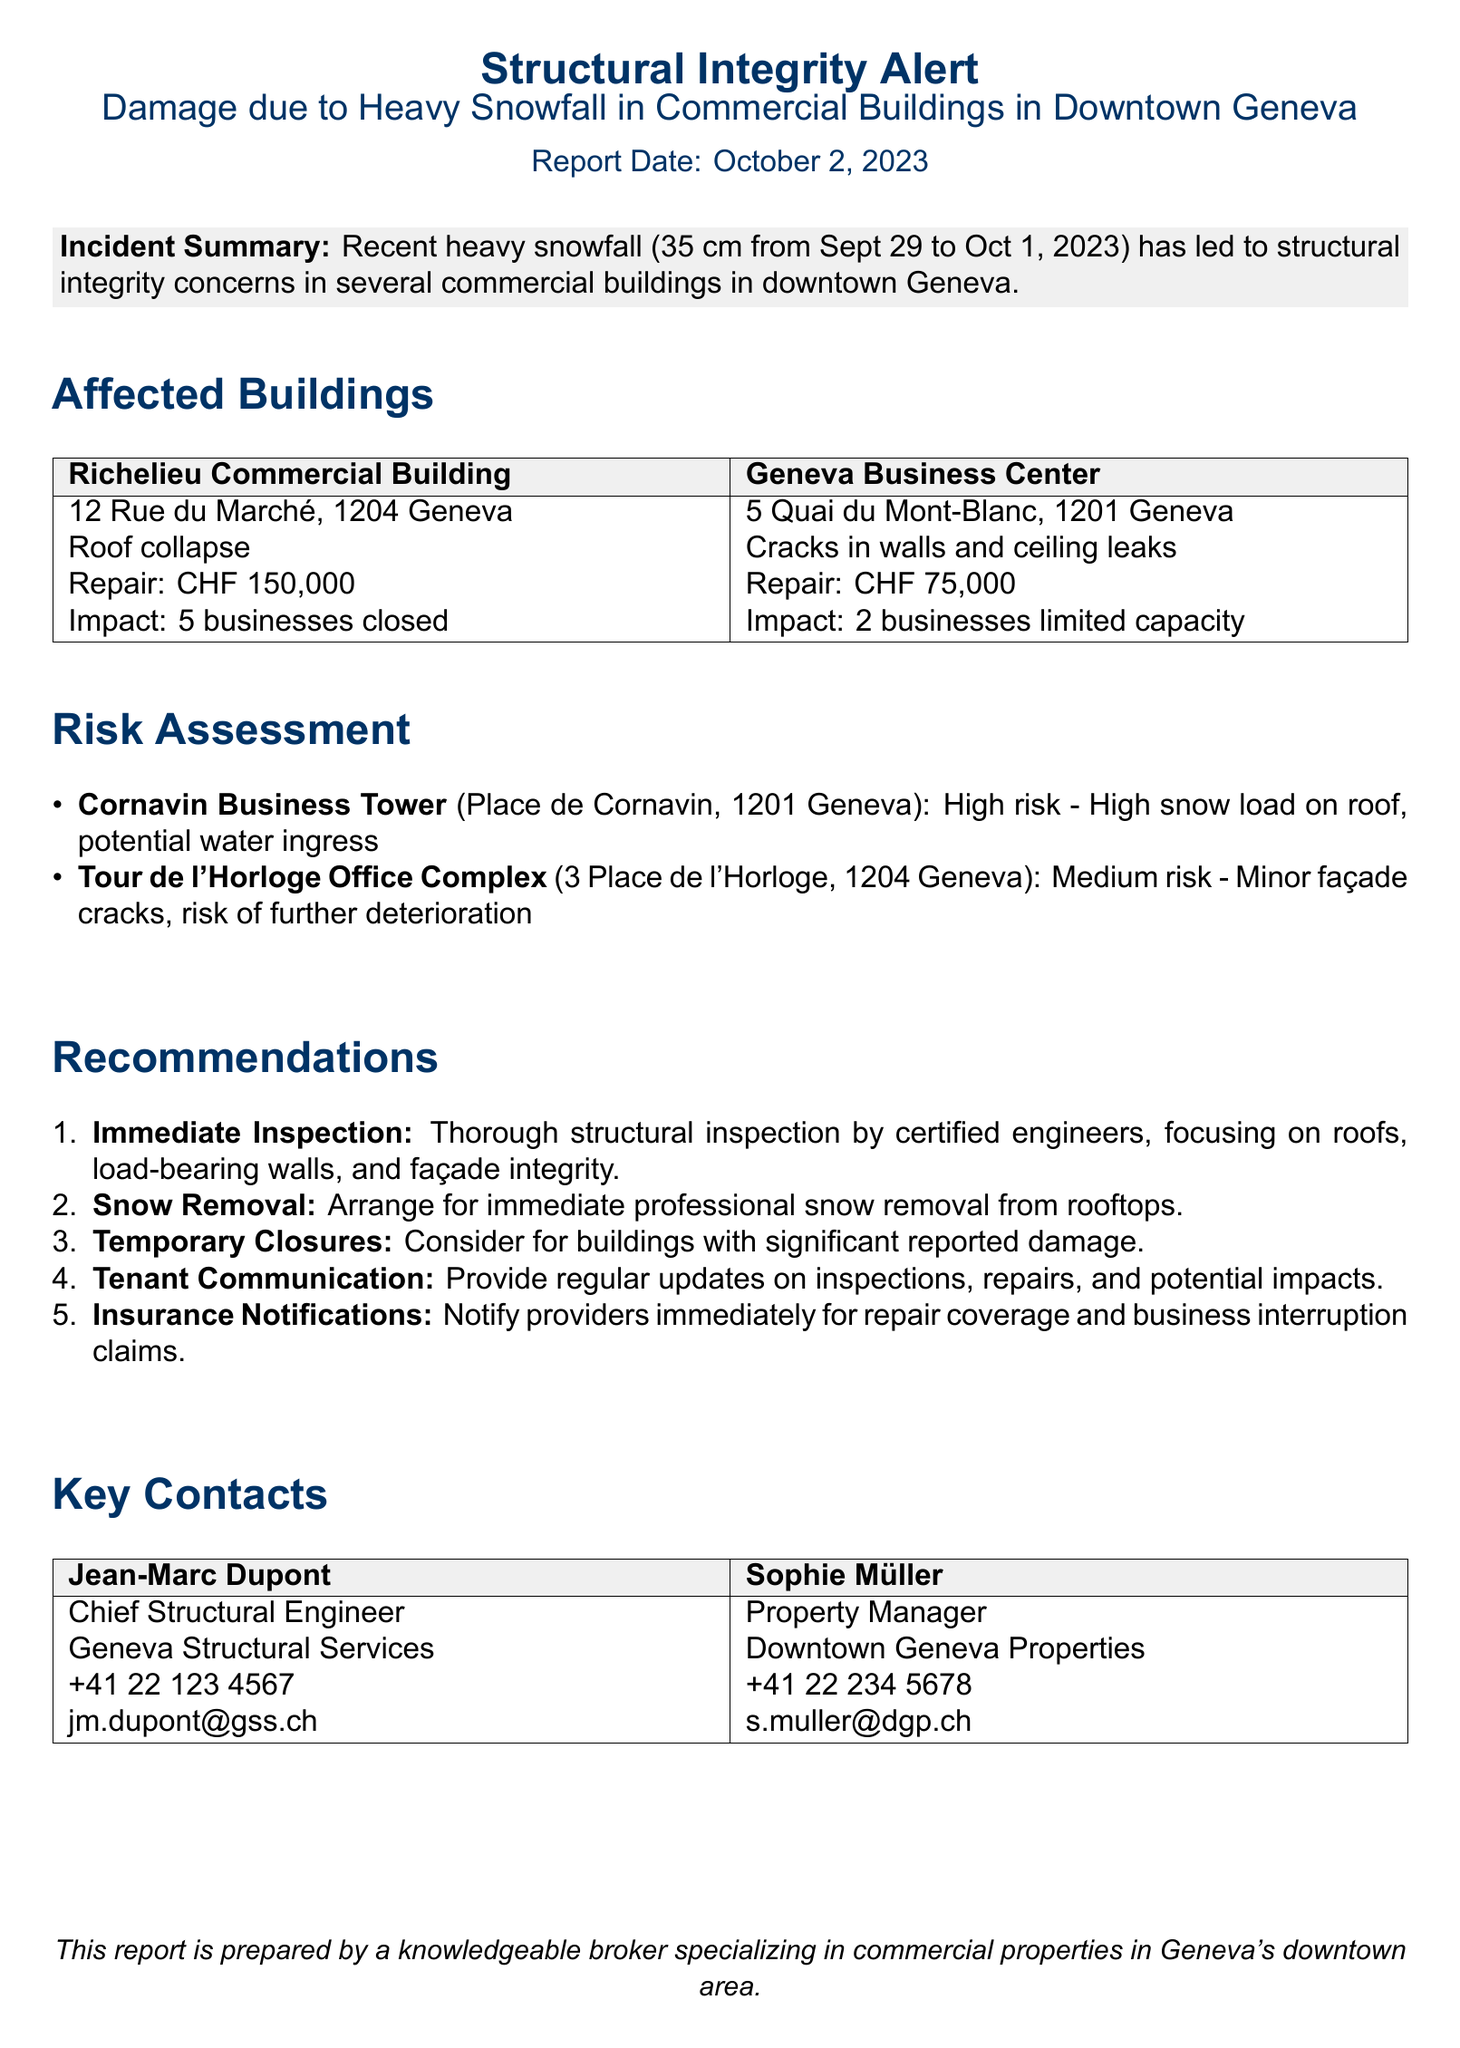What is the total snowfall recorded? The document states that recent heavy snowfall accumulated to 35 cm from September 29 to October 1, 2023.
Answer: 35 cm What is the repair cost for Richelieu Commercial Building? The repair cost for the Richelieu Commercial Building, as mentioned in the document, is CHF 150,000.
Answer: CHF 150,000 How many businesses were closed due to damage in Richelieu Commercial Building? The document specifies that 5 businesses were closed due to the damage in the Richelieu Commercial Building.
Answer: 5 businesses What is the risk assessment for Cornavin Business Tower? The document indicates that the risk assessment for Cornavin Business Tower is high risk due to high snow load and potential water ingress.
Answer: High risk What should be arranged for the rooftops as per recommendations? According to the recommendations, immediate professional snow removal should be arranged for rooftops.
Answer: Snow removal Who is the Chief Structural Engineer listed in the report? The Chief Structural Engineer mentioned in the document is Jean-Marc Dupont.
Answer: Jean-Marc Dupont What types of damage are reported in the Geneva Business Center? The reported damages in the Geneva Business Center are cracks in walls and ceiling leaks.
Answer: Cracks in walls and ceiling leaks How many businesses are operating at limited capacity in the Geneva Business Center? The document states that 2 businesses in the Geneva Business Center are operating at limited capacity.
Answer: 2 businesses What action is recommended for buildings with significant reported damage? The document recommends considering temporary closures for buildings with significant reported damage.
Answer: Temporary closures 